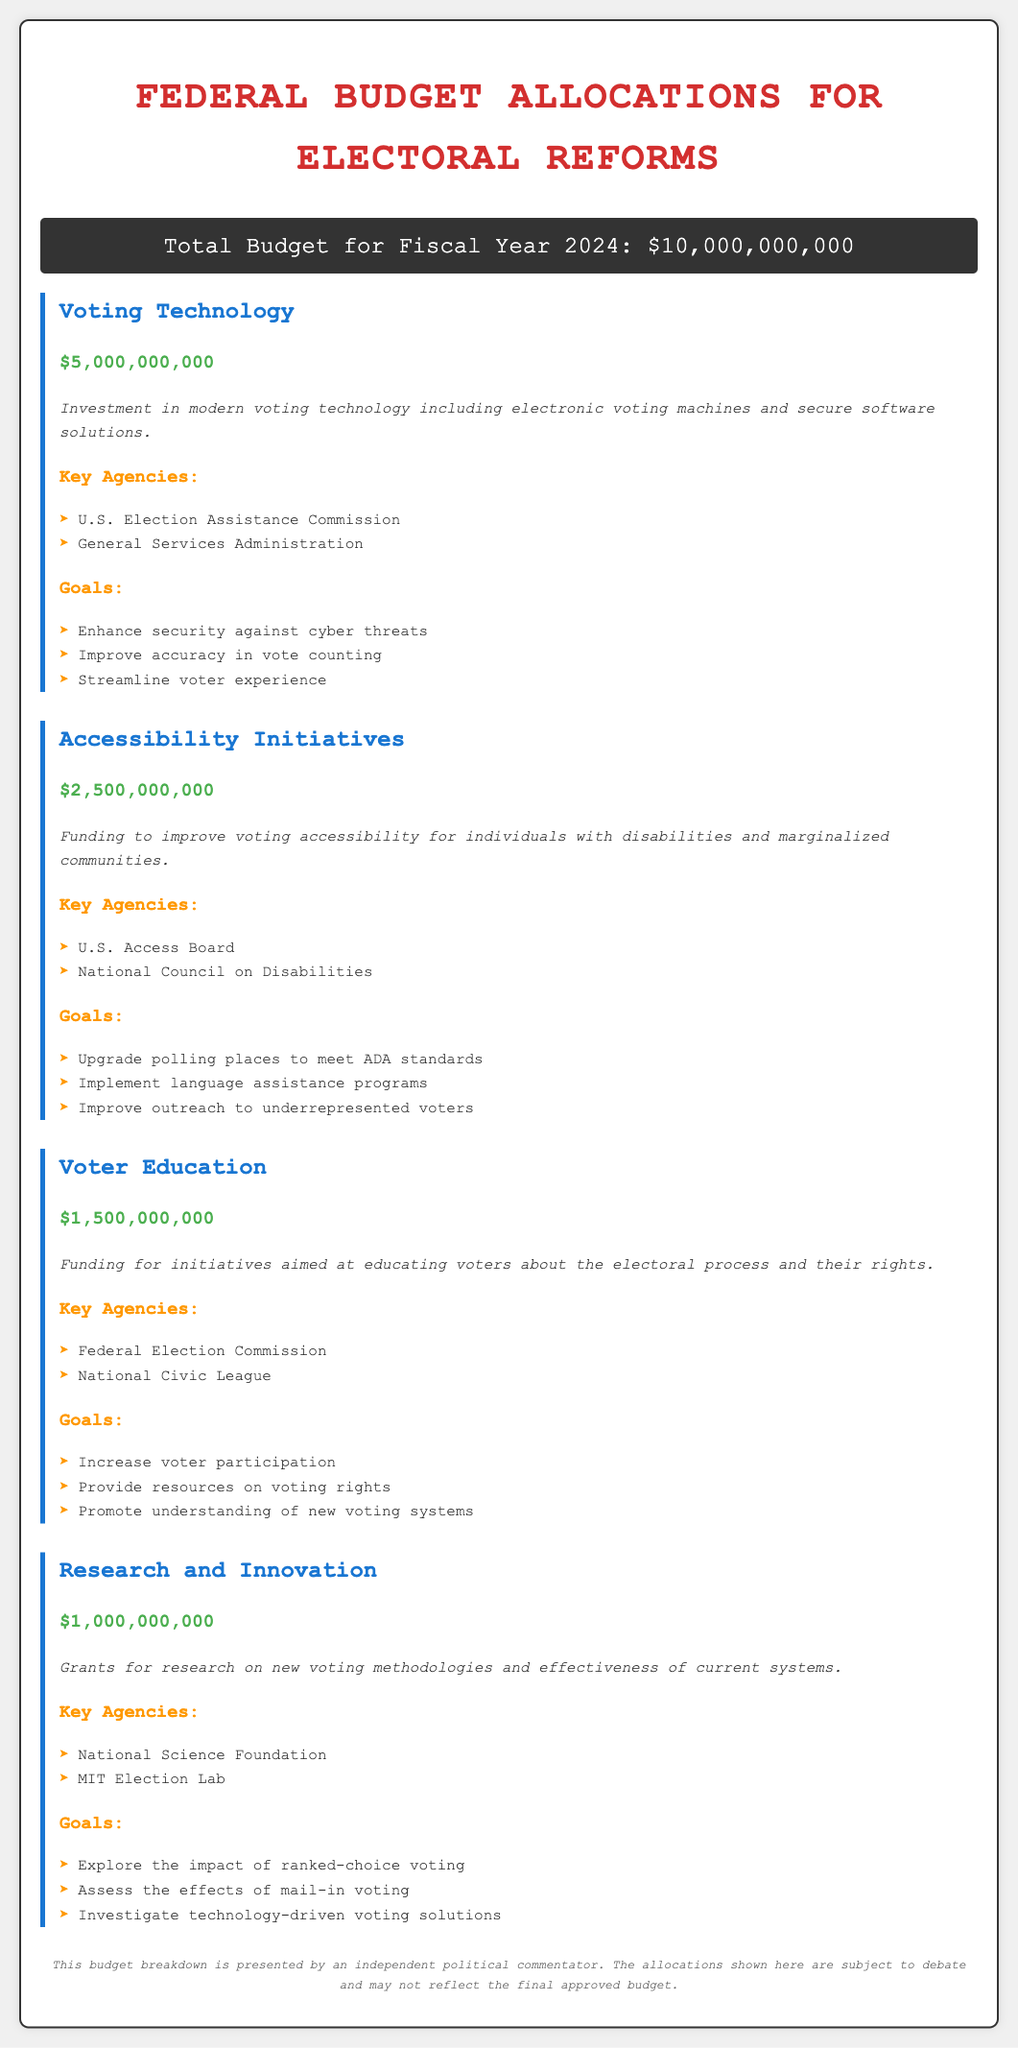What is the total budget for Fiscal Year 2024? The total budget is explicitly stated in the document as $10,000,000,000.
Answer: $10,000,000,000 How much is allocated for Voting Technology? The budget item for Voting Technology lists an amount of $5,000,000,000.
Answer: $5,000,000,000 Which agency is responsible for Accessibility Initiatives? The document lists the U.S. Access Board as a key agency for Accessibility Initiatives.
Answer: U.S. Access Board What are the goals for Voter Education? The goals for Voter Education include increasing voter participation, providing resources on voting rights, and promoting understanding of new voting systems.
Answer: Increase voter participation, provide resources on voting rights, promote understanding of new voting systems How much funding is designated for Research and Innovation? The document specifies that $1,000,000,000 is allocated for Research and Innovation.
Answer: $1,000,000,000 What is one goal of the Voting Technology allocation? One of the goals for Voting Technology is to enhance security against cyber threats.
Answer: Enhance security against cyber threats Which two agencies are involved in Voter Education funding? The funding for Voter Education is associated with the Federal Election Commission and the National Civic League.
Answer: Federal Election Commission, National Civic League How much money is set aside for Accessibility Initiatives? The document states that $2,500,000,000 is allocated for Accessibility Initiatives.
Answer: $2,500,000,000 